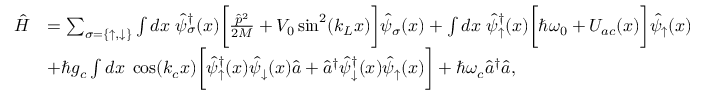Convert formula to latex. <formula><loc_0><loc_0><loc_500><loc_500>\begin{array} { r l } { \hat { H } } & { = \sum _ { \sigma = \{ \uparrow , \downarrow \} } \int d x \, \hat { \psi } _ { \sigma } ^ { \dag } ( x ) \left [ \frac { \hat { p } ^ { 2 } } { 2 M } + V _ { 0 } \sin ^ { 2 } ( k _ { L } x ) \right ] \hat { \psi } _ { \sigma } ( x ) + \int d x \, \hat { \psi } _ { \uparrow } ^ { \dag } ( x ) \left [ \hbar { \omega } _ { 0 } + U _ { a c } ( x ) \right ] \hat { \psi } _ { \uparrow } ( x ) } \\ & { + \hbar { g } _ { c } \int d x \, \cos ( k _ { c } x ) \left [ \hat { \psi } _ { \uparrow } ^ { \dag } ( x ) \hat { \psi } _ { \downarrow } ( x ) \hat { a } + \hat { a } ^ { \dag } \hat { \psi } _ { \downarrow } ^ { \dag } ( x ) \hat { \psi } _ { \uparrow } ( x ) \right ] + \hbar { \omega } _ { c } \hat { a } ^ { \dag } \hat { a } , } \end{array}</formula> 